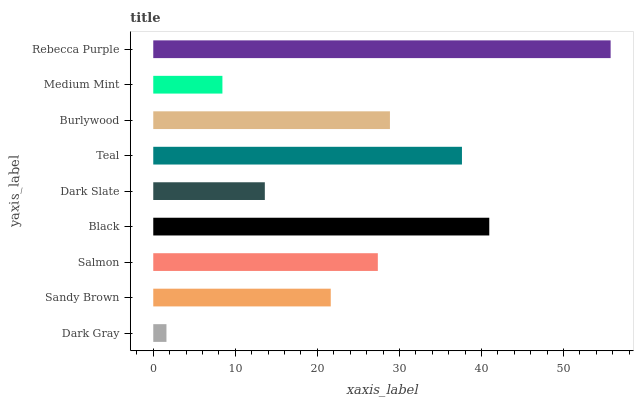Is Dark Gray the minimum?
Answer yes or no. Yes. Is Rebecca Purple the maximum?
Answer yes or no. Yes. Is Sandy Brown the minimum?
Answer yes or no. No. Is Sandy Brown the maximum?
Answer yes or no. No. Is Sandy Brown greater than Dark Gray?
Answer yes or no. Yes. Is Dark Gray less than Sandy Brown?
Answer yes or no. Yes. Is Dark Gray greater than Sandy Brown?
Answer yes or no. No. Is Sandy Brown less than Dark Gray?
Answer yes or no. No. Is Salmon the high median?
Answer yes or no. Yes. Is Salmon the low median?
Answer yes or no. Yes. Is Dark Slate the high median?
Answer yes or no. No. Is Rebecca Purple the low median?
Answer yes or no. No. 